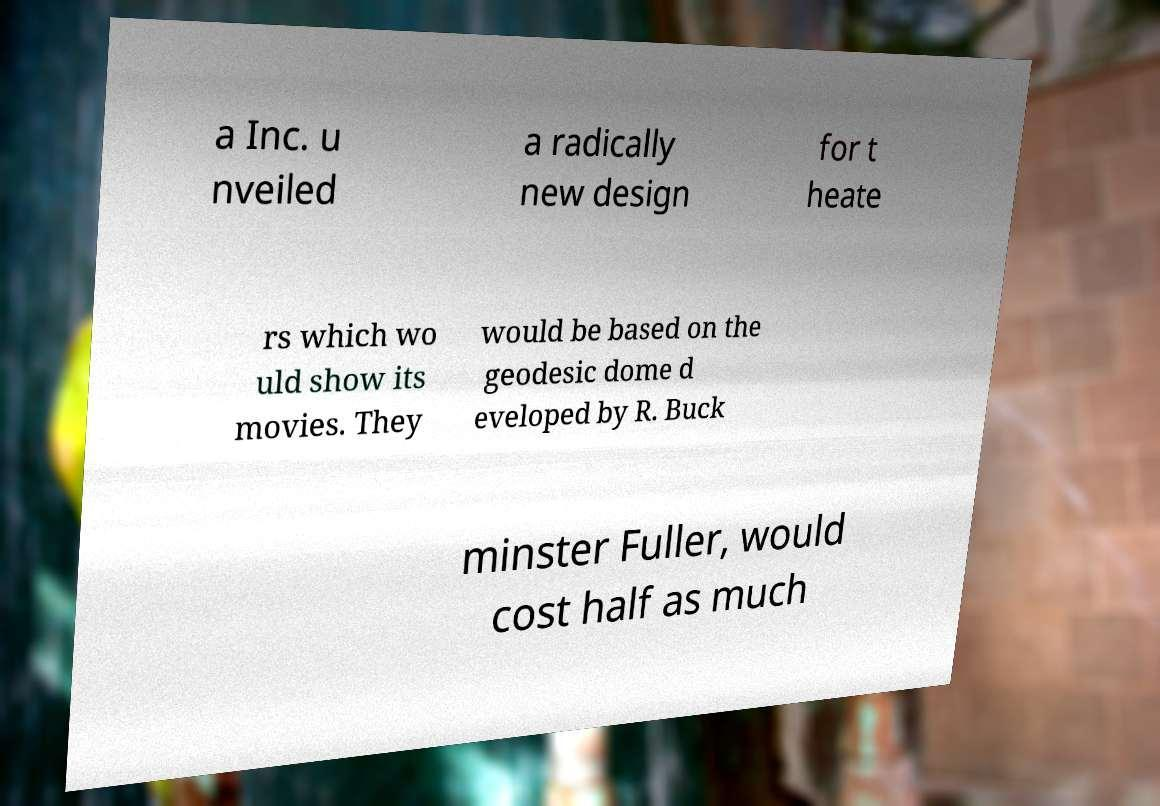Could you extract and type out the text from this image? a Inc. u nveiled a radically new design for t heate rs which wo uld show its movies. They would be based on the geodesic dome d eveloped by R. Buck minster Fuller, would cost half as much 